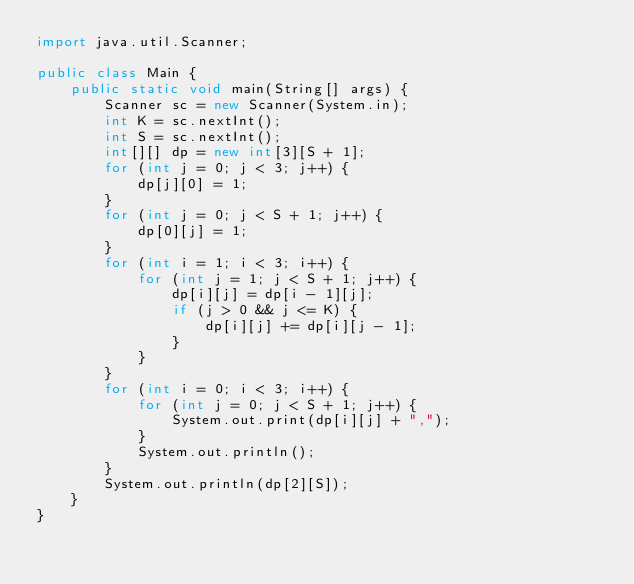<code> <loc_0><loc_0><loc_500><loc_500><_Java_>import java.util.Scanner;

public class Main {
	public static void main(String[] args) {
		Scanner sc = new Scanner(System.in);
		int K = sc.nextInt();
		int S = sc.nextInt();
		int[][] dp = new int[3][S + 1];
		for (int j = 0; j < 3; j++) {
			dp[j][0] = 1;
		}
		for (int j = 0; j < S + 1; j++) {
			dp[0][j] = 1;
		}
		for (int i = 1; i < 3; i++) {
			for (int j = 1; j < S + 1; j++) {
				dp[i][j] = dp[i - 1][j];
				if (j > 0 && j <= K) {
					dp[i][j] += dp[i][j - 1];
				}
			}
		}
		for (int i = 0; i < 3; i++) {
			for (int j = 0; j < S + 1; j++) {
				System.out.print(dp[i][j] + ",");
			}
			System.out.println();
		}
		System.out.println(dp[2][S]);
	}
}</code> 